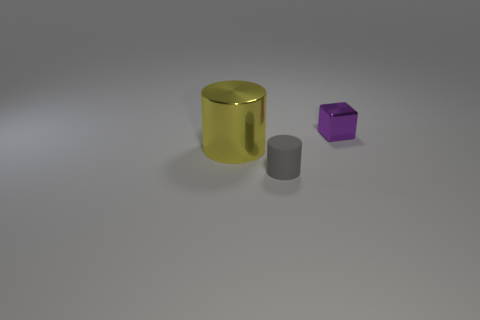Are there any other things that have the same material as the gray thing?
Your response must be concise. No. Are there any big metal things that have the same color as the shiny cylinder?
Ensure brevity in your answer.  No. What number of matte objects are either tiny yellow blocks or yellow things?
Give a very brief answer. 0. There is a object left of the matte thing; what number of tiny shiny cubes are in front of it?
Your answer should be very brief. 0. What number of other tiny objects are made of the same material as the yellow thing?
Make the answer very short. 1. What number of small objects are either yellow metal objects or cyan rubber spheres?
Provide a succinct answer. 0. What is the shape of the thing that is both right of the large metallic cylinder and in front of the small purple shiny object?
Offer a terse response. Cylinder. Is the tiny block made of the same material as the yellow cylinder?
Offer a terse response. Yes. The cube that is the same size as the gray cylinder is what color?
Offer a very short reply. Purple. What color is the thing that is both behind the small cylinder and to the right of the large thing?
Provide a succinct answer. Purple. 